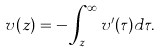<formula> <loc_0><loc_0><loc_500><loc_500>v ( z ) = - \int _ { z } ^ { \infty } v ^ { \prime } ( \tau ) d \tau .</formula> 